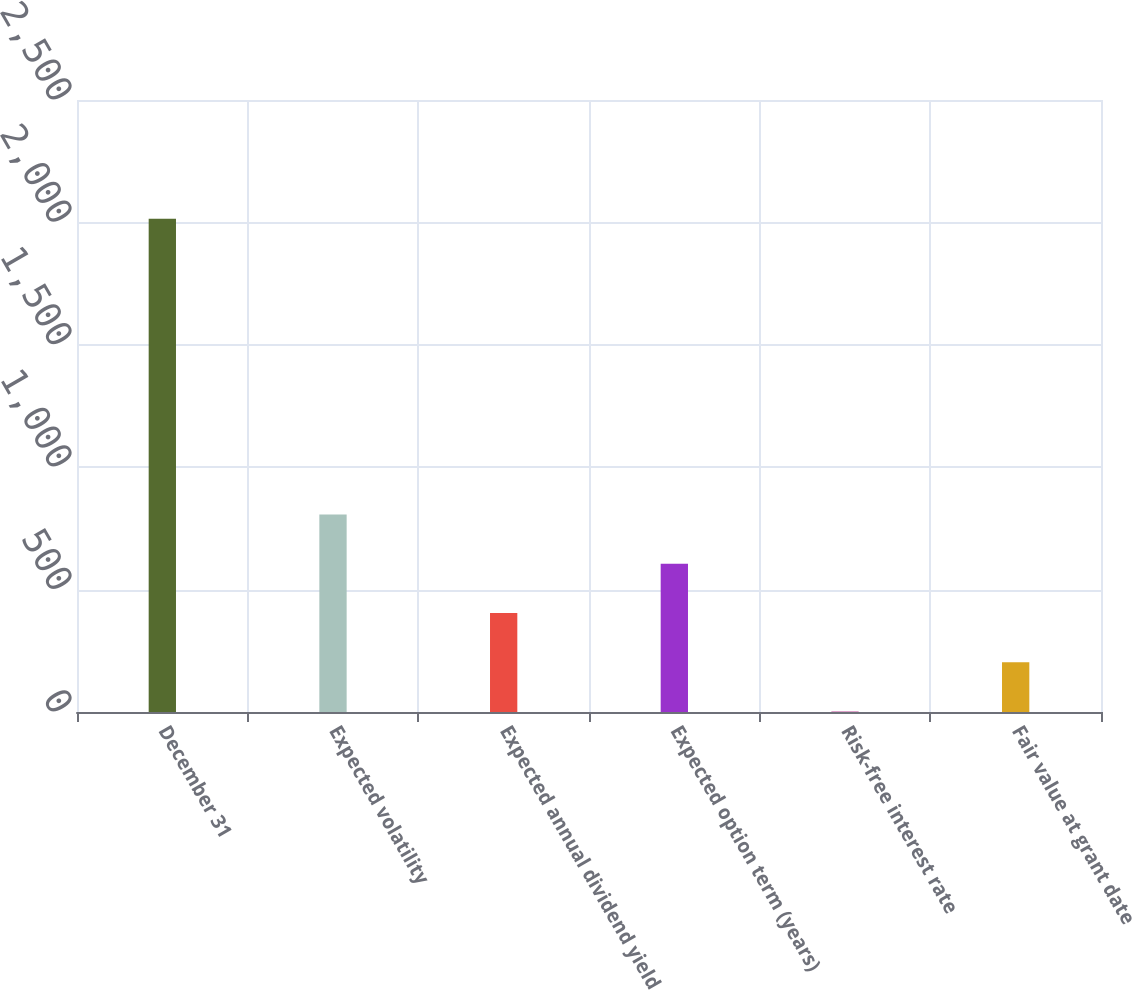Convert chart to OTSL. <chart><loc_0><loc_0><loc_500><loc_500><bar_chart><fcel>December 31<fcel>Expected volatility<fcel>Expected annual dividend yield<fcel>Expected option term (years)<fcel>Risk-free interest rate<fcel>Fair value at grant date<nl><fcel>2015<fcel>807.1<fcel>404.48<fcel>605.79<fcel>1.86<fcel>203.17<nl></chart> 